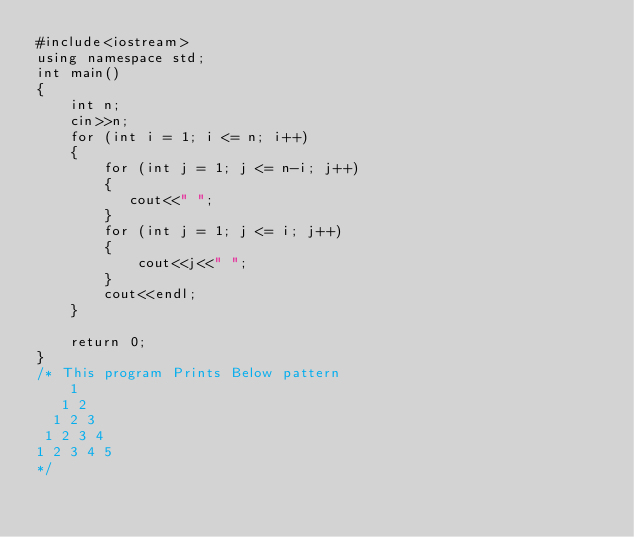Convert code to text. <code><loc_0><loc_0><loc_500><loc_500><_C++_>#include<iostream>
using namespace std;
int main()
{
    int n;
    cin>>n;
    for (int i = 1; i <= n; i++)
    {
        for (int j = 1; j <= n-i; j++)
        {
           cout<<" ";
        }
        for (int j = 1; j <= i; j++)
        {
            cout<<j<<" ";
        }
        cout<<endl;
    }
    
    return 0;
}
/* This program Prints Below pattern
    1
   1 2
  1 2 3
 1 2 3 4
1 2 3 4 5
*/</code> 